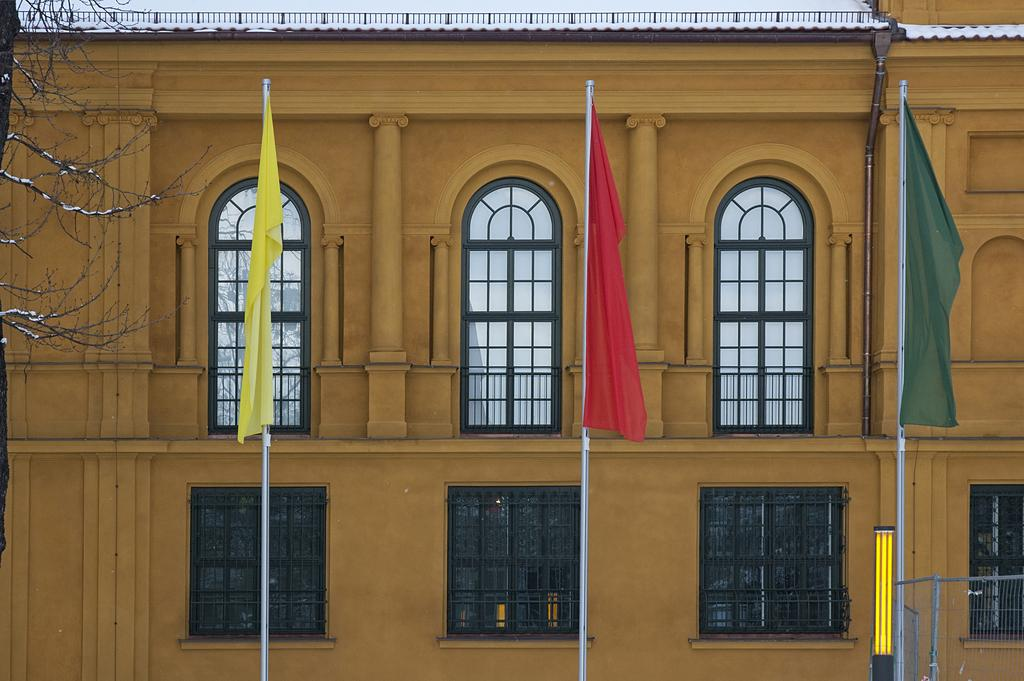What is the color of the building in the image? The building in the image is yellow. What type of windows does the building have? The building has glass windows. What can be seen in front of the building? There are three colorful flags in front of the building. How many bushes are surrounding the building in the image? There is no mention of bushes in the image; the provided facts only mention the yellow building, glass windows, and colorful flags. 